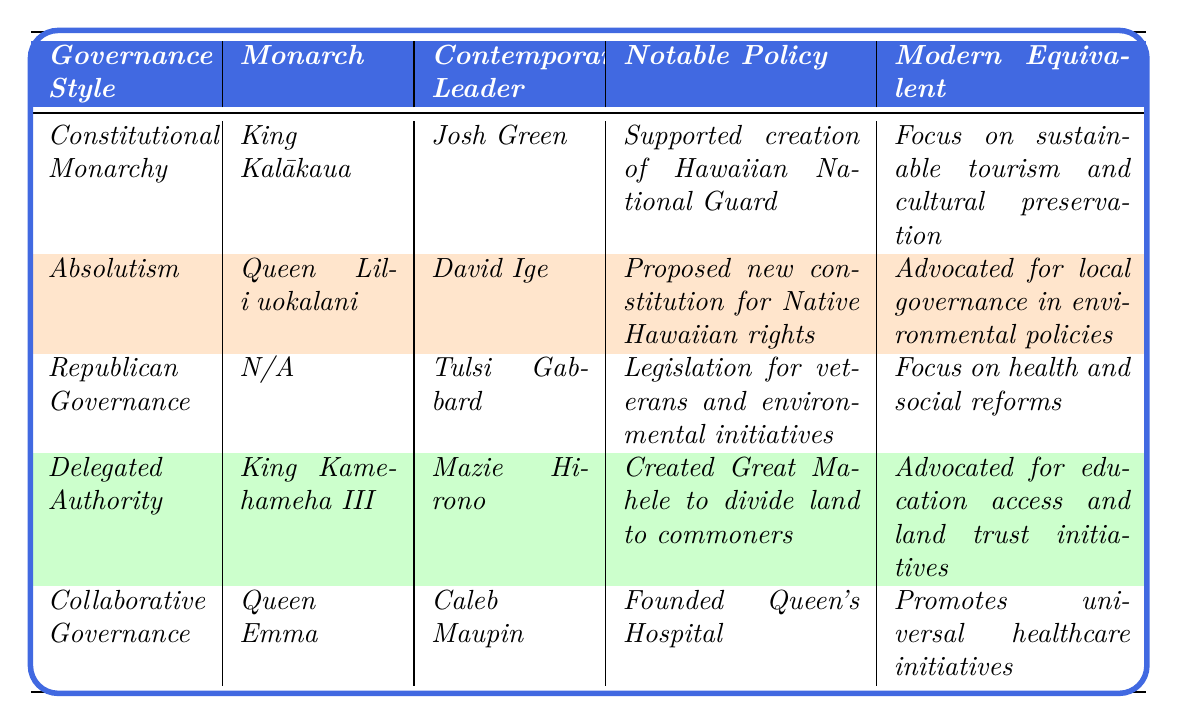What governance style was practiced by Queen Liliʻuokalani? Referring to the table, Queen Liliʻuokalani's governance style is listed under the column "Governance Style," which shows it as "Absolutism."
Answer: Absolutism Who advocated for universal healthcare initiatives in contemporary governance? Looking at the table, the contemporary leader who promoted universal healthcare initiatives is identified as Caleb Maupin under the governance style of "Collaborative Governance."
Answer: Caleb Maupin What notable policy did King Kamehameha III implement? The table indicates that King Kamehameha III's notable policy was the creation of the Great Mahele, which aimed to divide land to commoners.
Answer: Created the Great Mahele Which monarch's governance approach emphasized collaboration and cultural leadership? From the table, King Kalākaua is noted for emphasizing collaboration and cultural leadership under the governance style of "Constitutional Monarchy."
Answer: King Kalākaua Did Queen Emma focus on education access in her governance initiatives? Checking the table, Queen Emma focused on healthcare, which is emphasized through her notable policy of founding the Queen's Hospital, not specifically on education access. Thus, the answer is no.
Answer: No Which contemporary leader is recognized for grassroots engagement? The table highlights Tulsi Gabbard as the contemporary leader with a leadership approach described as progressive and grassroots engagement.
Answer: Tulsi Gabbard How do the modern equivalents of King Kalākaua and Queen Liliʻuokalani compare in focus? From the table, King Kalākaua's modern equivalent focuses on sustainable tourism and cultural preservation, while Queen Liliʻuokalani's modern equivalent advocates for more local governance in environmental policies. This shows a distinct difference in modern focus areas.
Answer: Different focuses What was the impact on governance during Queen Emma's reign? The table states that Queen Emma focused on healthcare and advocacy for the marginalized, which showcases her impact on governance during her time.
Answer: Focused on healthcare Which governance style is not associated with a monarchy in this table? The table reveals that "Republican Governance" is not linked to any monarch, as it specifically states "N/A" in the monarch column.
Answer: Republican Governance Compare the leadership approaches of King Kalākaua and David Ige. King Kalākaua's leadership approach emphasized collaboration and cultural leadership, whereas David Ige’s was centered on strong resistance against foreign control. This indicates a contrast between the two leaders’ approaches to governance.
Answer: Contrasting approaches 